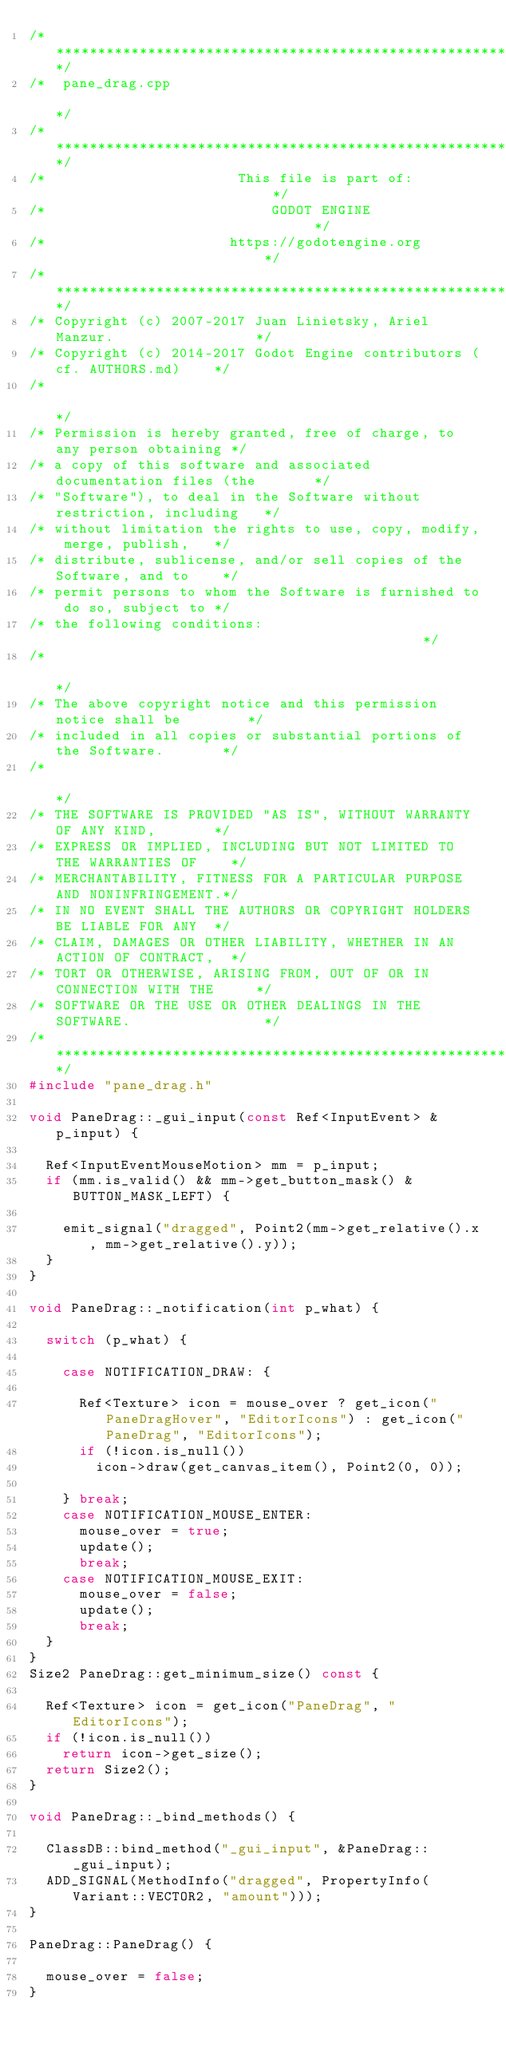Convert code to text. <code><loc_0><loc_0><loc_500><loc_500><_C++_>/*************************************************************************/
/*  pane_drag.cpp                                                        */
/*************************************************************************/
/*                       This file is part of:                           */
/*                           GODOT ENGINE                                */
/*                      https://godotengine.org                          */
/*************************************************************************/
/* Copyright (c) 2007-2017 Juan Linietsky, Ariel Manzur.                 */
/* Copyright (c) 2014-2017 Godot Engine contributors (cf. AUTHORS.md)    */
/*                                                                       */
/* Permission is hereby granted, free of charge, to any person obtaining */
/* a copy of this software and associated documentation files (the       */
/* "Software"), to deal in the Software without restriction, including   */
/* without limitation the rights to use, copy, modify, merge, publish,   */
/* distribute, sublicense, and/or sell copies of the Software, and to    */
/* permit persons to whom the Software is furnished to do so, subject to */
/* the following conditions:                                             */
/*                                                                       */
/* The above copyright notice and this permission notice shall be        */
/* included in all copies or substantial portions of the Software.       */
/*                                                                       */
/* THE SOFTWARE IS PROVIDED "AS IS", WITHOUT WARRANTY OF ANY KIND,       */
/* EXPRESS OR IMPLIED, INCLUDING BUT NOT LIMITED TO THE WARRANTIES OF    */
/* MERCHANTABILITY, FITNESS FOR A PARTICULAR PURPOSE AND NONINFRINGEMENT.*/
/* IN NO EVENT SHALL THE AUTHORS OR COPYRIGHT HOLDERS BE LIABLE FOR ANY  */
/* CLAIM, DAMAGES OR OTHER LIABILITY, WHETHER IN AN ACTION OF CONTRACT,  */
/* TORT OR OTHERWISE, ARISING FROM, OUT OF OR IN CONNECTION WITH THE     */
/* SOFTWARE OR THE USE OR OTHER DEALINGS IN THE SOFTWARE.                */
/*************************************************************************/
#include "pane_drag.h"

void PaneDrag::_gui_input(const Ref<InputEvent> &p_input) {

	Ref<InputEventMouseMotion> mm = p_input;
	if (mm.is_valid() && mm->get_button_mask() & BUTTON_MASK_LEFT) {

		emit_signal("dragged", Point2(mm->get_relative().x, mm->get_relative().y));
	}
}

void PaneDrag::_notification(int p_what) {

	switch (p_what) {

		case NOTIFICATION_DRAW: {

			Ref<Texture> icon = mouse_over ? get_icon("PaneDragHover", "EditorIcons") : get_icon("PaneDrag", "EditorIcons");
			if (!icon.is_null())
				icon->draw(get_canvas_item(), Point2(0, 0));

		} break;
		case NOTIFICATION_MOUSE_ENTER:
			mouse_over = true;
			update();
			break;
		case NOTIFICATION_MOUSE_EXIT:
			mouse_over = false;
			update();
			break;
	}
}
Size2 PaneDrag::get_minimum_size() const {

	Ref<Texture> icon = get_icon("PaneDrag", "EditorIcons");
	if (!icon.is_null())
		return icon->get_size();
	return Size2();
}

void PaneDrag::_bind_methods() {

	ClassDB::bind_method("_gui_input", &PaneDrag::_gui_input);
	ADD_SIGNAL(MethodInfo("dragged", PropertyInfo(Variant::VECTOR2, "amount")));
}

PaneDrag::PaneDrag() {

	mouse_over = false;
}
</code> 